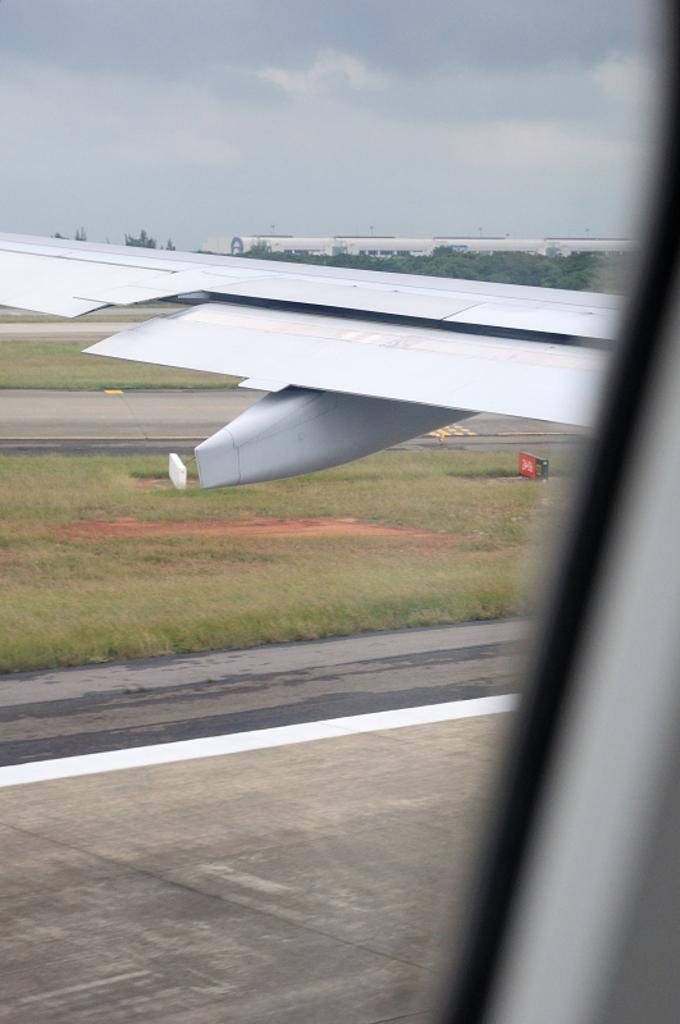What part of an airplane is visible in the image? There is a side wing of an airplane in the image. What is the ground surface like in the image? The ground is covered with grass. What can be seen behind the airplane? There are trees behind the airplane. What is located behind the trees in the image? There are buildings behind the trees. How would you describe the sky in the image? The sky is cloudy. What type of stocking is hanging from the trees in the image? There are no stockings present in the image; it features an airplane wing, grassy ground, trees, buildings, and a cloudy sky. 